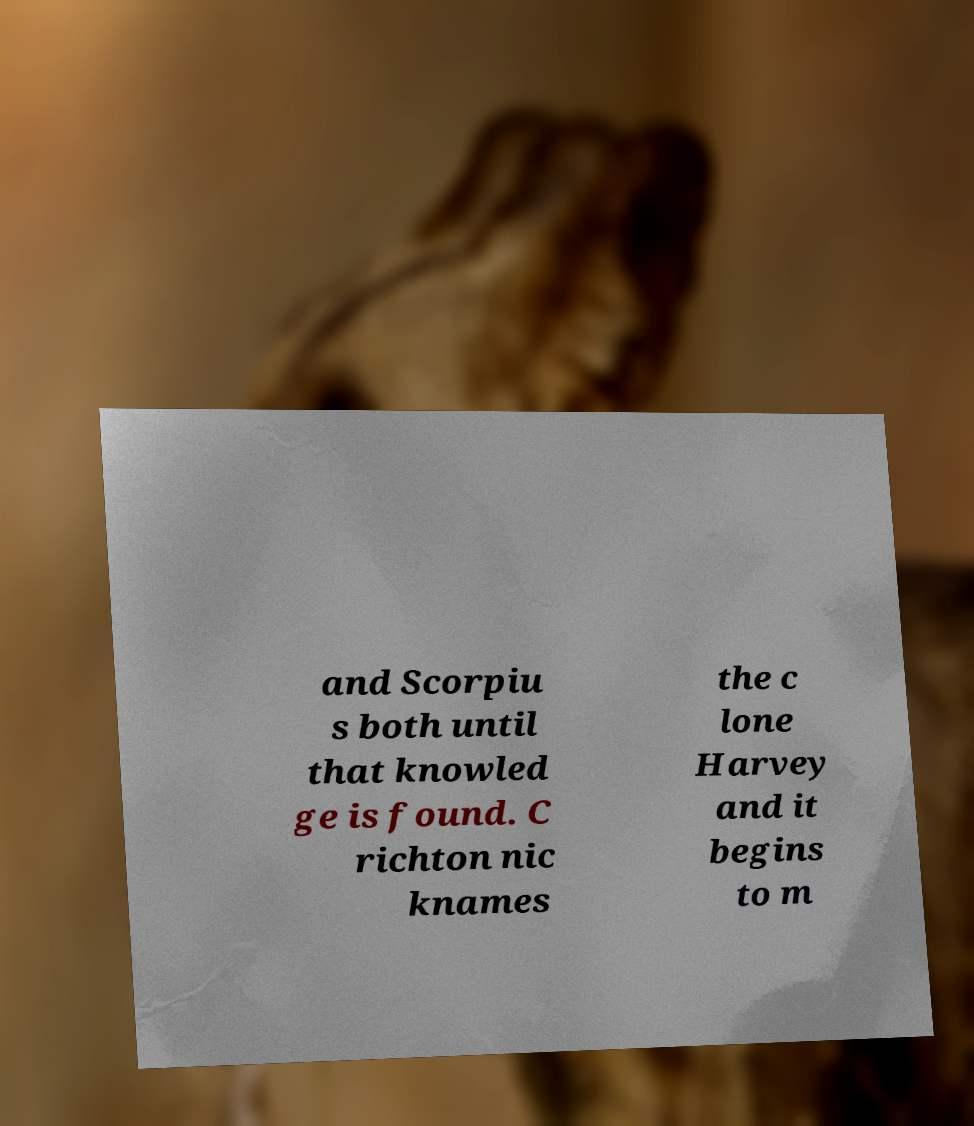Can you read and provide the text displayed in the image?This photo seems to have some interesting text. Can you extract and type it out for me? and Scorpiu s both until that knowled ge is found. C richton nic knames the c lone Harvey and it begins to m 